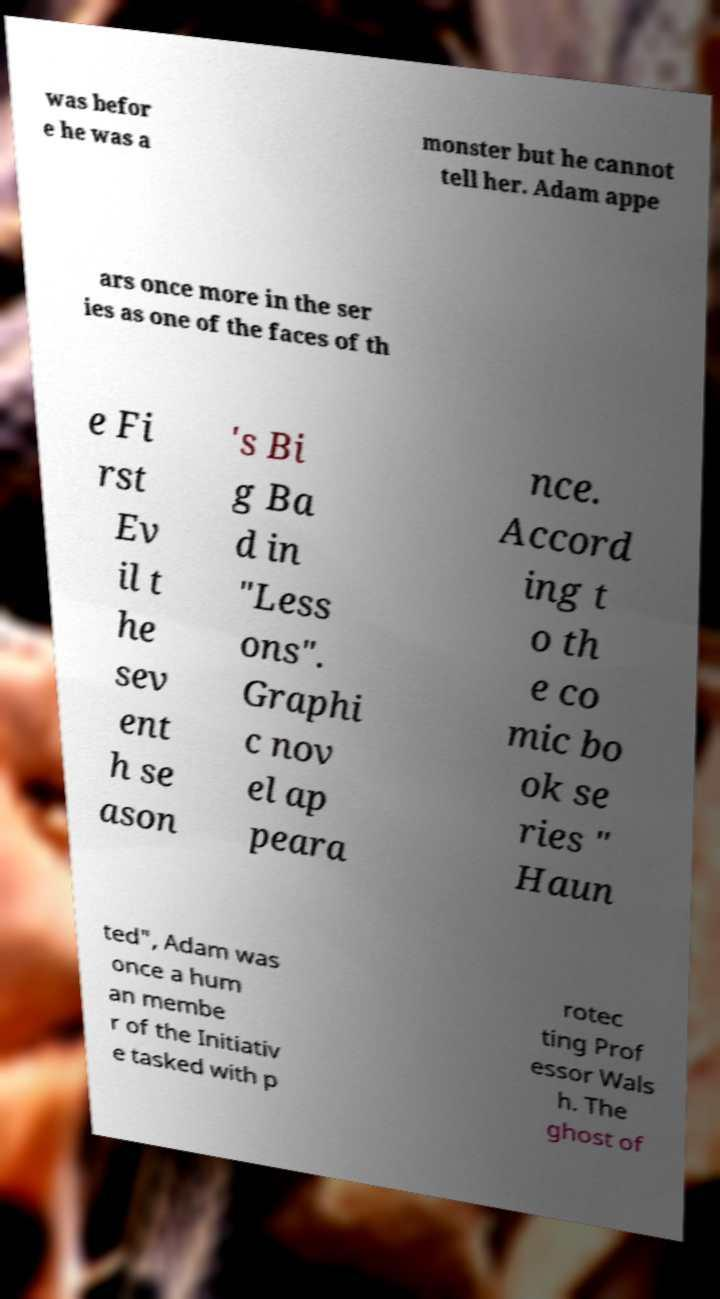For documentation purposes, I need the text within this image transcribed. Could you provide that? was befor e he was a monster but he cannot tell her. Adam appe ars once more in the ser ies as one of the faces of th e Fi rst Ev il t he sev ent h se ason 's Bi g Ba d in "Less ons". Graphi c nov el ap peara nce. Accord ing t o th e co mic bo ok se ries " Haun ted", Adam was once a hum an membe r of the Initiativ e tasked with p rotec ting Prof essor Wals h. The ghost of 